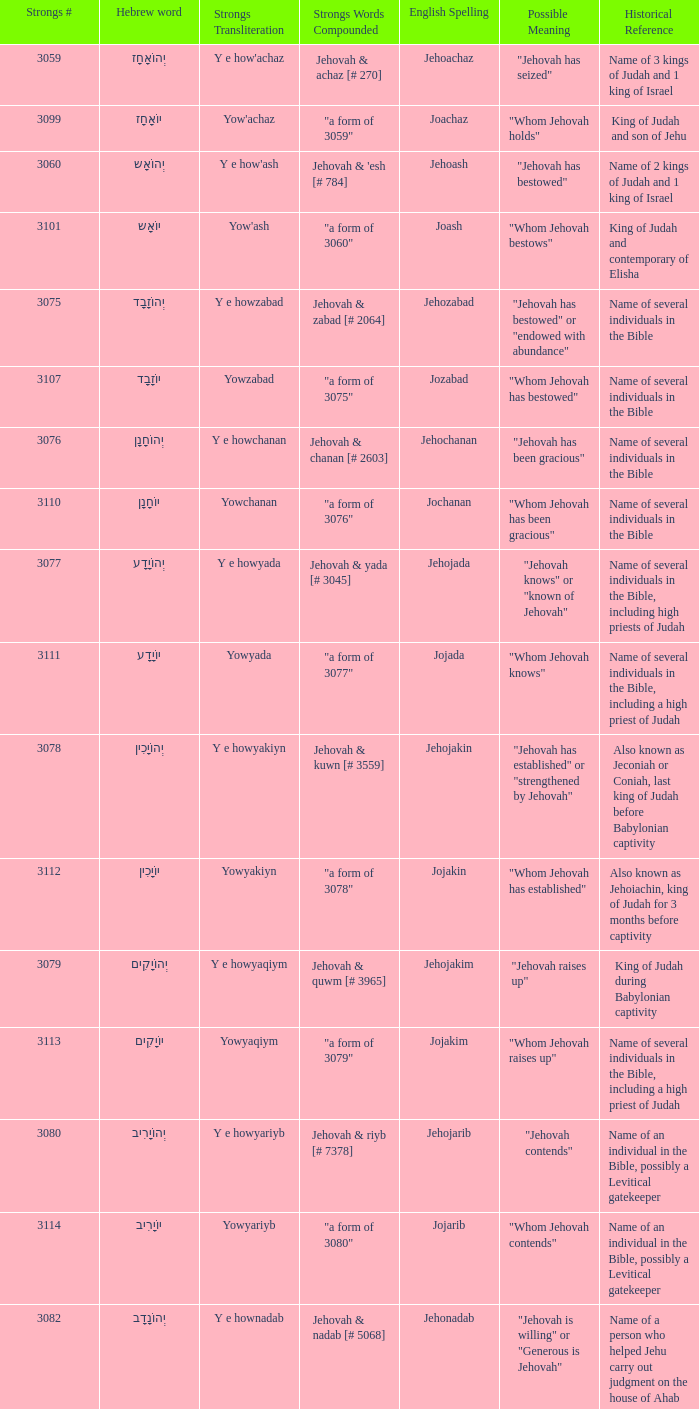Can you give me this table as a dict? {'header': ['Strongs #', 'Hebrew word', 'Strongs Transliteration', 'Strongs Words Compounded', 'English Spelling', 'Possible Meaning', 'Historical Reference'], 'rows': [['3059', 'יְהוֹאָחָז', "Y e how'achaz", 'Jehovah & achaz [# 270]', 'Jehoachaz', '"Jehovah has seized"', 'Name of 3 kings of Judah and 1 king of Israel'], ['3099', 'יוֹאָחָז', "Yow'achaz", '"a form of 3059"', 'Joachaz', '"Whom Jehovah holds"', 'King of Judah and son of Jehu'], ['3060', 'יְהוֹאָש', "Y e how'ash", "Jehovah & 'esh [# 784]", 'Jehoash', '"Jehovah has bestowed"', 'Name of 2 kings of Judah and 1 king of Israel'], ['3101', 'יוֹאָש', "Yow'ash", '"a form of 3060"', 'Joash', '"Whom Jehovah bestows"', 'King of Judah and contemporary of Elisha'], ['3075', 'יְהוֹזָבָד', 'Y e howzabad', 'Jehovah & zabad [# 2064]', 'Jehozabad', '"Jehovah has bestowed" or "endowed with abundance"', 'Name of several individuals in the Bible'], ['3107', 'יוֹזָבָד', 'Yowzabad', '"a form of 3075"', 'Jozabad', '"Whom Jehovah has bestowed"', 'Name of several individuals in the Bible'], ['3076', 'יְהוֹחָנָן', 'Y e howchanan', 'Jehovah & chanan [# 2603]', 'Jehochanan', '"Jehovah has been gracious"', 'Name of several individuals in the Bible'], ['3110', 'יוֹחָנָן', 'Yowchanan', '"a form of 3076"', 'Jochanan', '"Whom Jehovah has been gracious"', 'Name of several individuals in the Bible'], ['3077', 'יְהוֹיָדָע', 'Y e howyada', 'Jehovah & yada [# 3045]', 'Jehojada', '"Jehovah knows" or "known of Jehovah"', 'Name of several individuals in the Bible, including high priests of Judah'], ['3111', 'יוֹיָדָע', 'Yowyada', '"a form of 3077"', 'Jojada', '"Whom Jehovah knows"', 'Name of several individuals in the Bible, including a high priest of Judah'], ['3078', 'יְהוֹיָכִין', 'Y e howyakiyn', 'Jehovah & kuwn [# 3559]', 'Jehojakin', '"Jehovah has established" or "strengthened by Jehovah"', 'Also known as Jeconiah or Coniah, last king of Judah before Babylonian captivity'], ['3112', 'יוֹיָכִין', 'Yowyakiyn', '"a form of 3078"', 'Jojakin', '"Whom Jehovah has established"', 'Also known as Jehoiachin, king of Judah for 3 months before captivity'], ['3079', 'יְהוֹיָקִים', 'Y e howyaqiym', 'Jehovah & quwm [# 3965]', 'Jehojakim', '"Jehovah raises up"', 'King of Judah during Babylonian captivity'], ['3113', 'יוֹיָקִים', 'Yowyaqiym', '"a form of 3079"', 'Jojakim', '"Whom Jehovah raises up"', 'Name of several individuals in the Bible, including a high priest of Judah'], ['3080', 'יְהוֹיָרִיב', 'Y e howyariyb', 'Jehovah & riyb [# 7378]', 'Jehojarib', '"Jehovah contends"', 'Name of an individual in the Bible, possibly a Levitical gatekeeper'], ['3114', 'יוֹיָרִיב', 'Yowyariyb', '"a form of 3080"', 'Jojarib', '"Whom Jehovah contends"', 'Name of an individual in the Bible, possibly a Levitical gatekeeper'], ['3082', 'יְהוֹנָדָב', 'Y e hownadab', 'Jehovah & nadab [# 5068]', 'Jehonadab', '"Jehovah is willing" or "Generous is Jehovah"', 'Name of a person who helped Jehu carry out judgment on the house of Ahab'], ['3122', 'יוֹנָדָב', 'Yownadab', '"a form of 3082"', 'Jonadab', '"Whom God is willing"', 'Bible character who was praised for his faithfulness to his family traditions'], ['3083', 'יְהוֹנָתָן', 'Y e hownathan', 'Jehovah & nathan [# 5414]', 'Jehonathan', '"Jehovah has given"', 'Name of son of king Saul and close friend of David'], ['3129', 'יוֹנָתָן', 'Yownathan', '"a form of 3083"', 'Jonathan', '"Whom Jehovah has given"', 'Name of several individuals in the Bible'], ['3085', 'יְהוֹעַדָּה', "Y e how'addah", "Jehovah & 'adah [# 5710]", 'Jehoaddah', '"Jehovah has adorned" or "adorned by Jehovah"', 'Name of a woman mentioned in King James Version (KJV) Bible'], ['3087', 'יְהוֹצָדָק', 'Y e howtsadaq', 'Jehovah & tsadaq [# 6663]', 'Jehotsadak', '"Jehovah is righteous" or "Righteousness of Jehovah"', 'High priest who helped lead the rebuilding of the temple under Zerubbabel after Babylonian exile'], ['3136', 'יוֹצָדָק', 'Yowtsadaq', '"a form of 3087"', 'Jotsadak', '"Whom Jehovah is righteous"', 'Name of several individuals in the Bible'], ['3088', 'יְהוֹרָם', 'Y e howram', 'Jehovah & ruwm [# 7311]', 'Jehoram', '"Jehovah is exalted"', 'Name of 2 kings of Judah and 1 king of Israel in the Old Testament'], ['3141', 'יוֹרָם', 'Yowram', '"a form of 3088"', 'Joram', '"Whom Jehovah exalts"', 'Name of several individuals in the Bible'], ['3092', 'יְהוֹשָפָט', 'Y e howshaphat', 'Jehovah & shaphat [# 8199]', 'Jehoshaphat', '"Jehovah has judged"', 'King of Judah who is noted for his reforms and battles against neighboring nations.']]} What is the strongs # of the english spelling word jehojakin? 3078.0. 